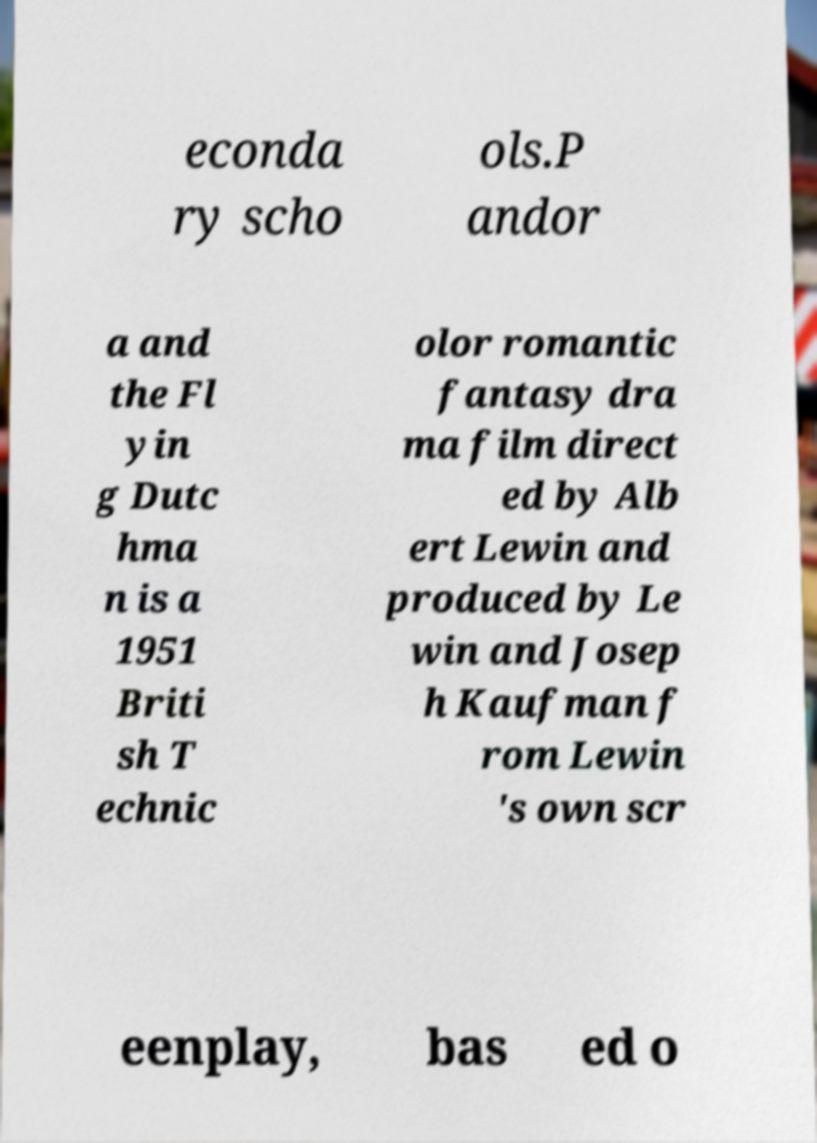I need the written content from this picture converted into text. Can you do that? econda ry scho ols.P andor a and the Fl yin g Dutc hma n is a 1951 Briti sh T echnic olor romantic fantasy dra ma film direct ed by Alb ert Lewin and produced by Le win and Josep h Kaufman f rom Lewin 's own scr eenplay, bas ed o 